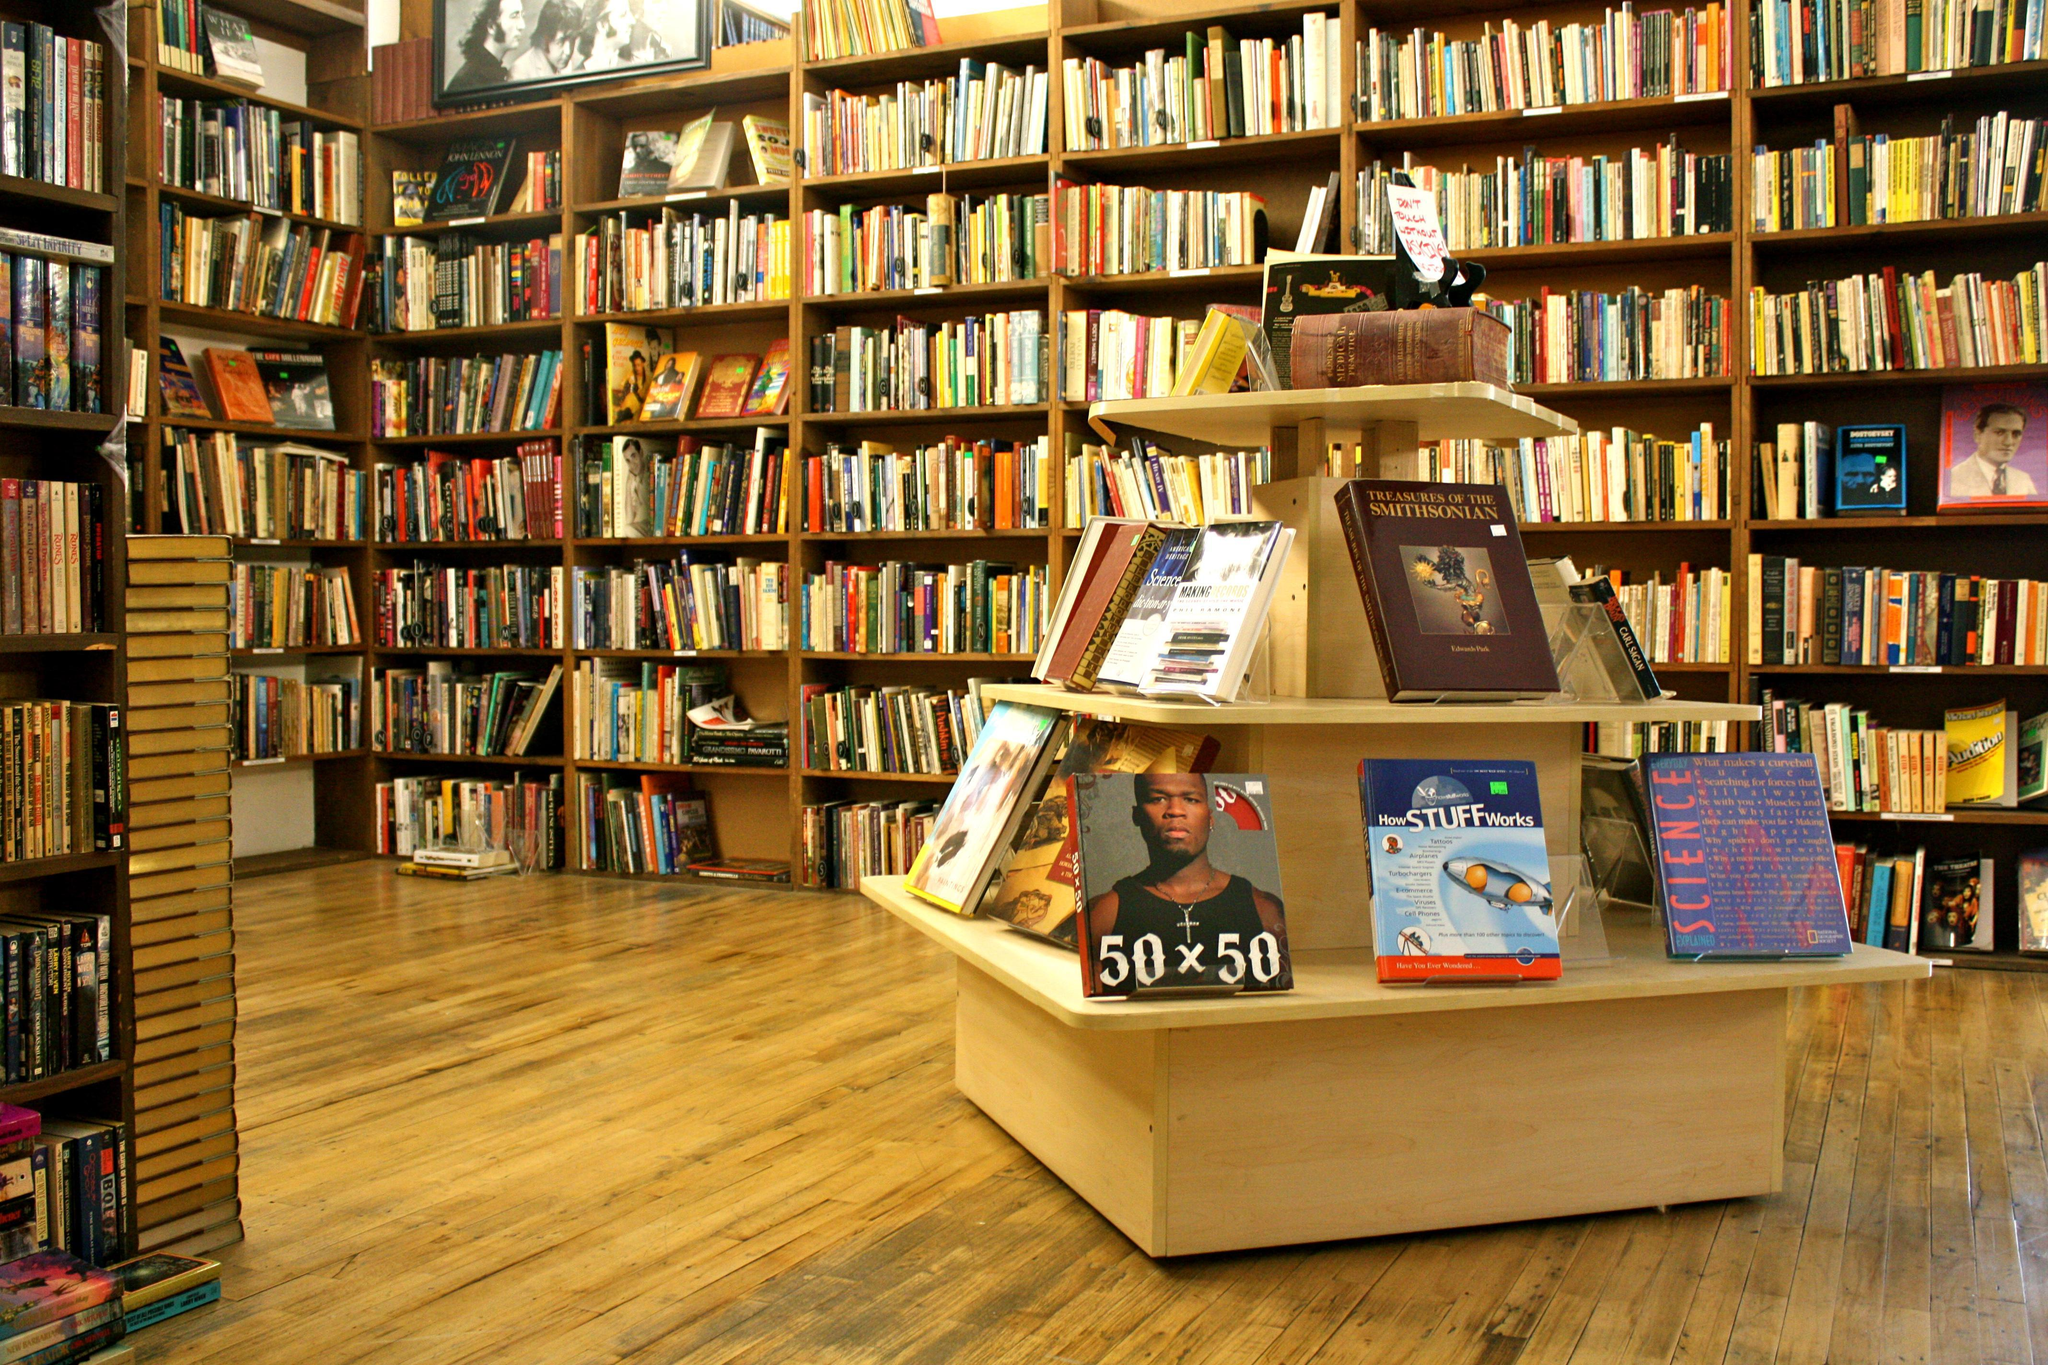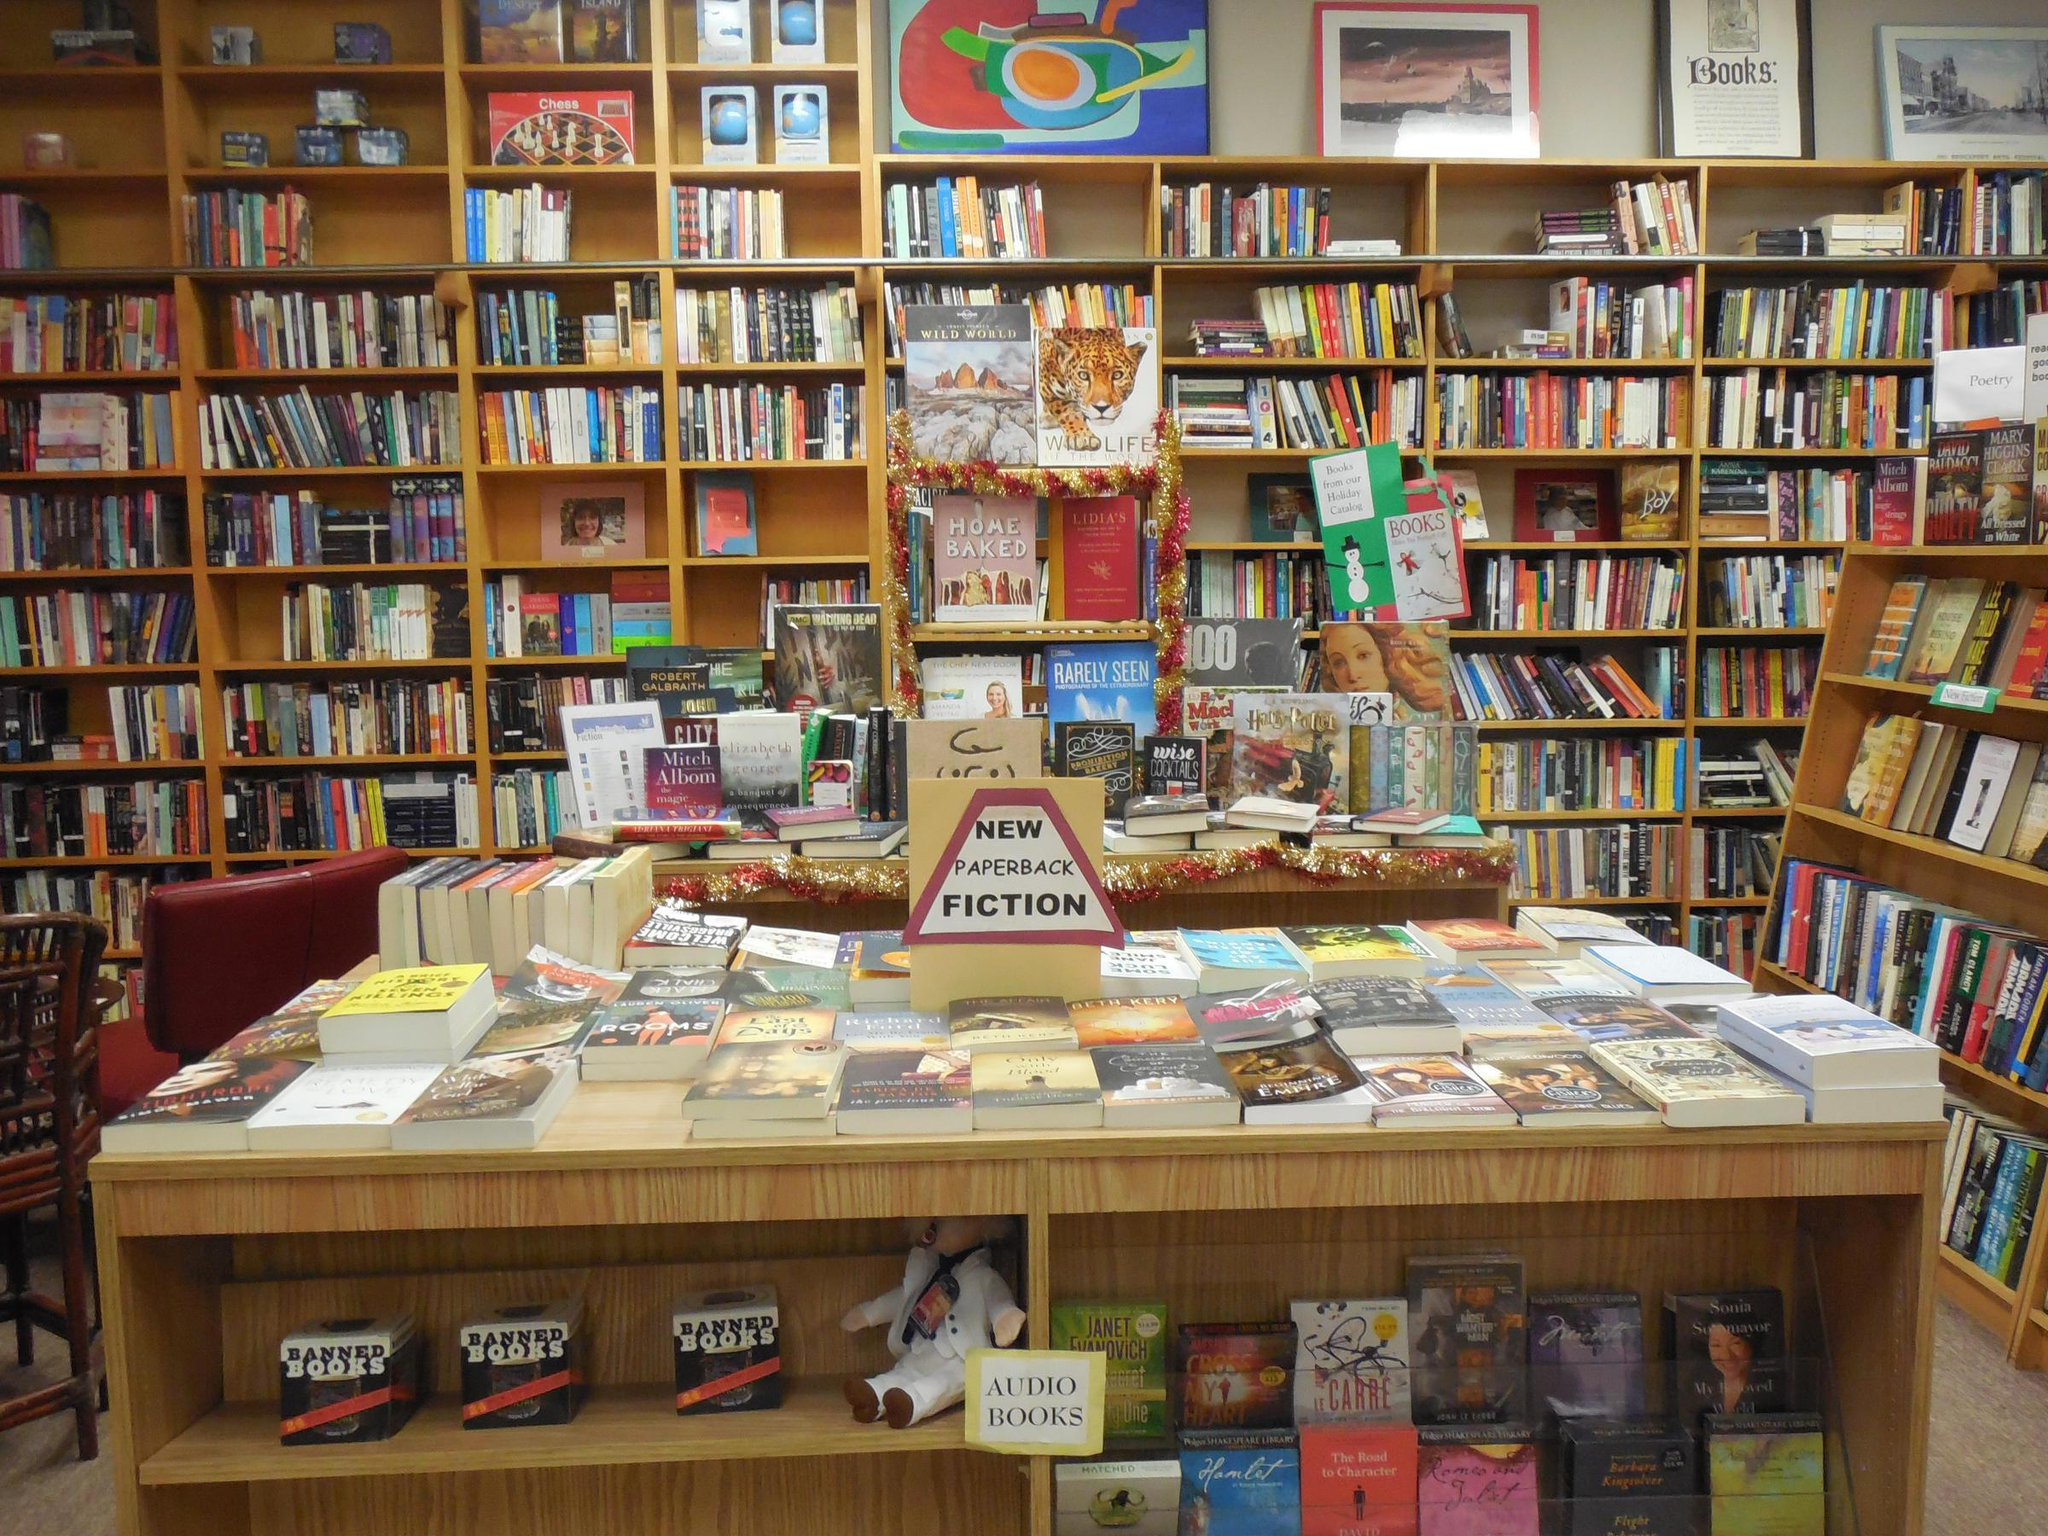The first image is the image on the left, the second image is the image on the right. Evaluate the accuracy of this statement regarding the images: "There is at least one person in the image on the left.". Is it true? Answer yes or no. No. 